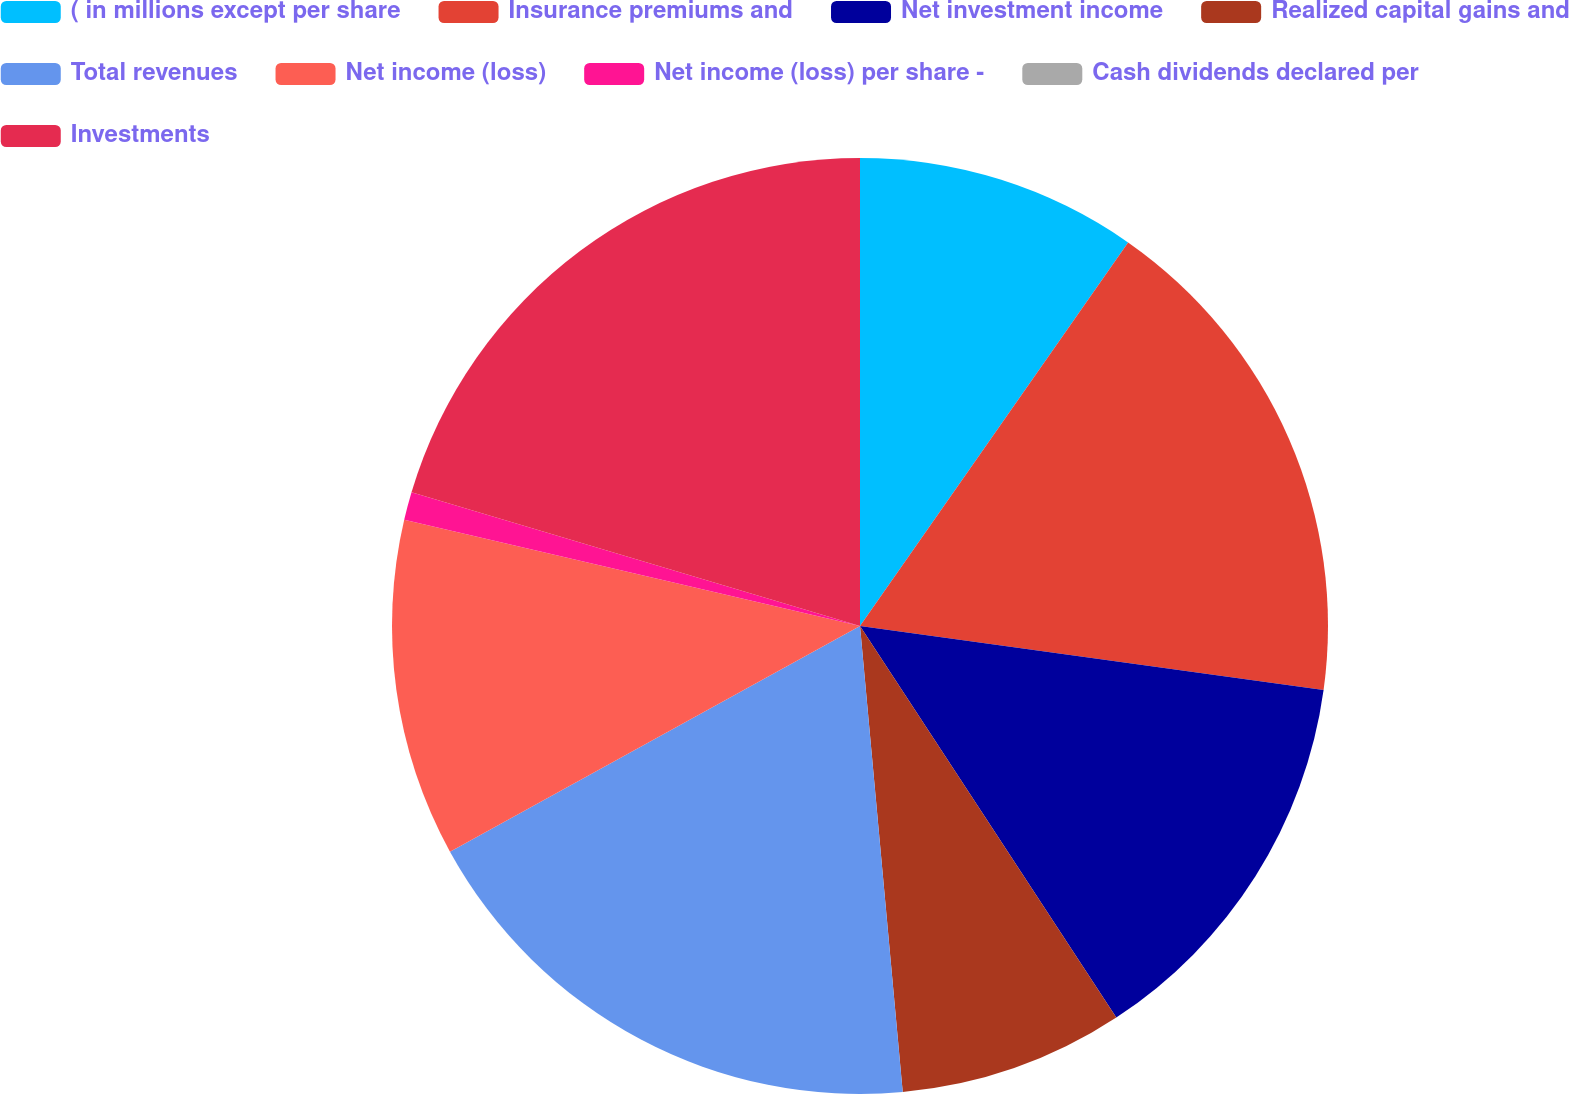<chart> <loc_0><loc_0><loc_500><loc_500><pie_chart><fcel>( in millions except per share<fcel>Insurance premiums and<fcel>Net investment income<fcel>Realized capital gains and<fcel>Total revenues<fcel>Net income (loss)<fcel>Net income (loss) per share -<fcel>Cash dividends declared per<fcel>Investments<nl><fcel>9.71%<fcel>17.48%<fcel>13.59%<fcel>7.77%<fcel>18.45%<fcel>11.65%<fcel>0.97%<fcel>0.0%<fcel>20.39%<nl></chart> 